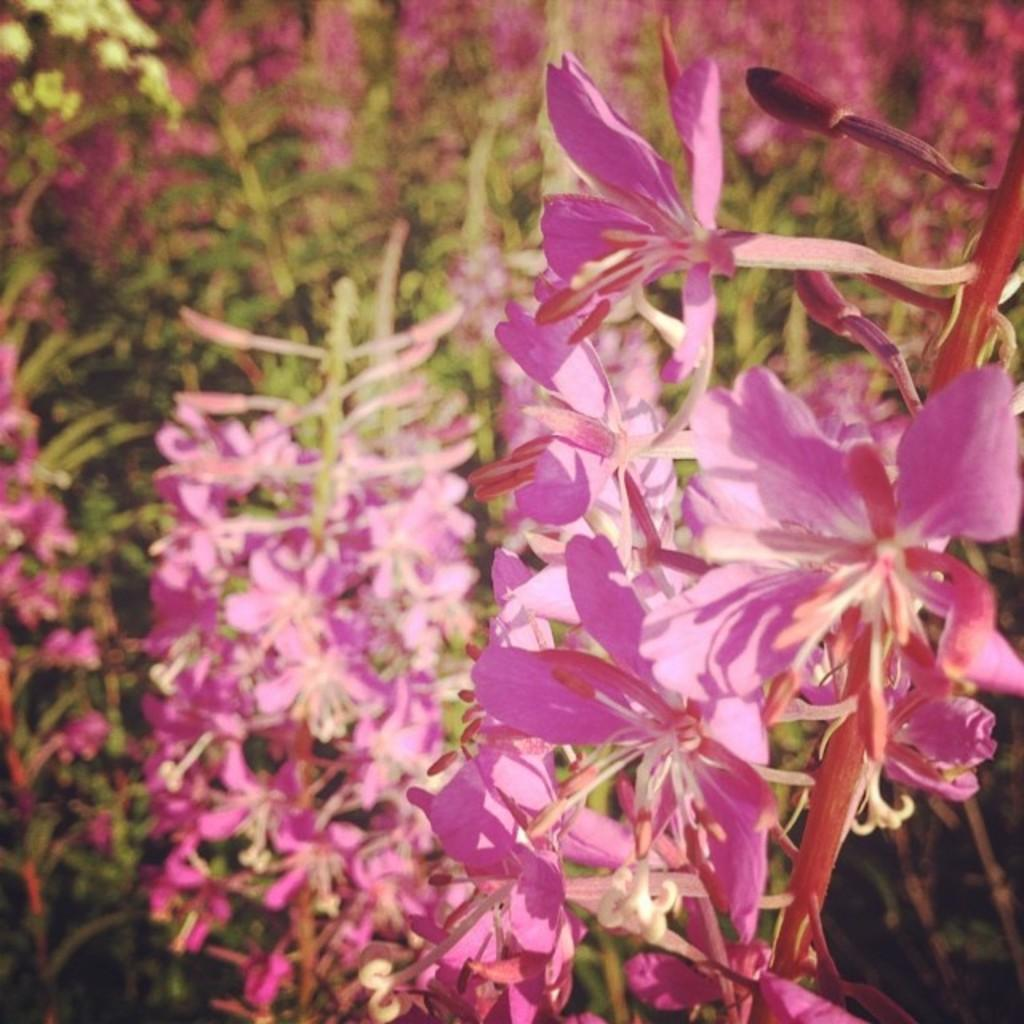What type of plant is in the image? There is a flower plant in the image. What color are the flowers on the plant? The flowers on the plant are pink. How is the background of the image depicted? The background of the plant is blurred. Can you see a kite flying in the background of the image? There is no kite present in the image; the background is blurred and only shows the plant and its flowers. 